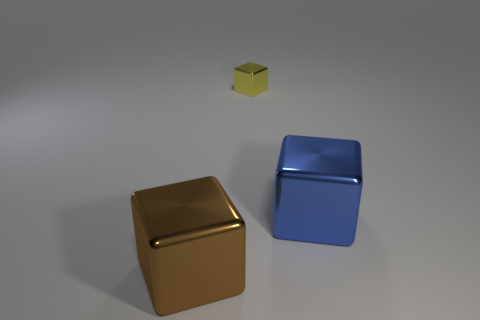Is there any other thing that is the same size as the yellow metallic object?
Offer a terse response. No. What is the color of the large metal thing that is to the right of the large metal thing to the left of the large block that is to the right of the tiny metal object?
Ensure brevity in your answer.  Blue. What number of shiny cubes have the same color as the small metal object?
Keep it short and to the point. 0. What number of large things are either cubes or blue objects?
Provide a succinct answer. 2. Is there another yellow shiny object of the same shape as the yellow thing?
Ensure brevity in your answer.  No. Is the shape of the blue thing the same as the big brown shiny thing?
Give a very brief answer. Yes. There is a large cube to the right of the brown metal thing that is left of the tiny thing; what color is it?
Offer a very short reply. Blue. What color is the other object that is the same size as the brown metal object?
Offer a terse response. Blue. What number of matte things are green cylinders or blue blocks?
Give a very brief answer. 0. There is a object that is to the left of the small shiny cube; what number of tiny metal cubes are left of it?
Your answer should be very brief. 0. 